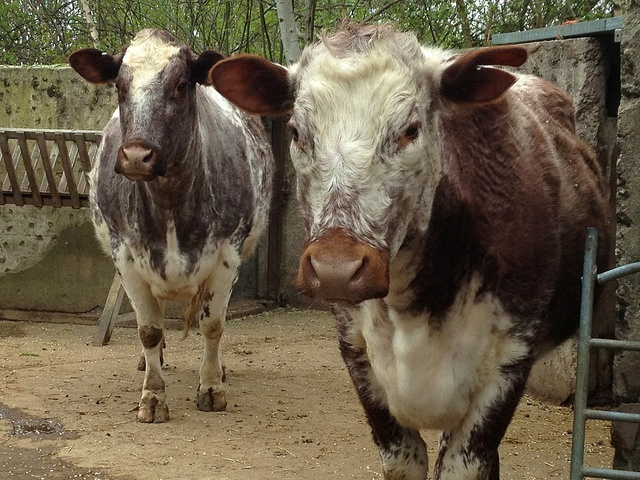Describe the objects in this image and their specific colors. I can see cow in green, black, gray, and maroon tones and cow in olive, black, and gray tones in this image. 